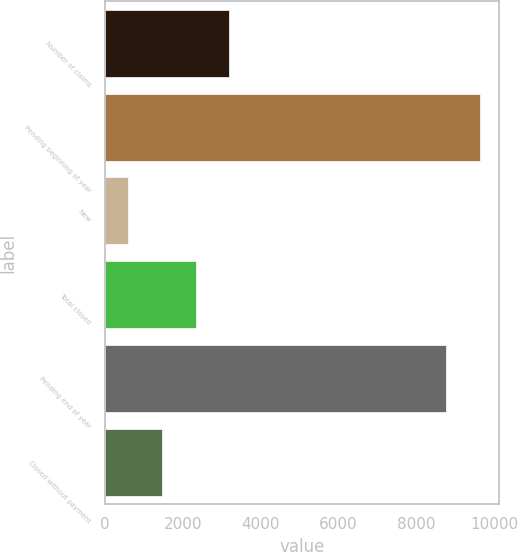Convert chart to OTSL. <chart><loc_0><loc_0><loc_500><loc_500><bar_chart><fcel>Number of claims<fcel>Pending beginning of year<fcel>New<fcel>Total closed<fcel>Pending end of year<fcel>Closed without payment<nl><fcel>3197.5<fcel>9645.5<fcel>601<fcel>2332<fcel>8780<fcel>1466.5<nl></chart> 